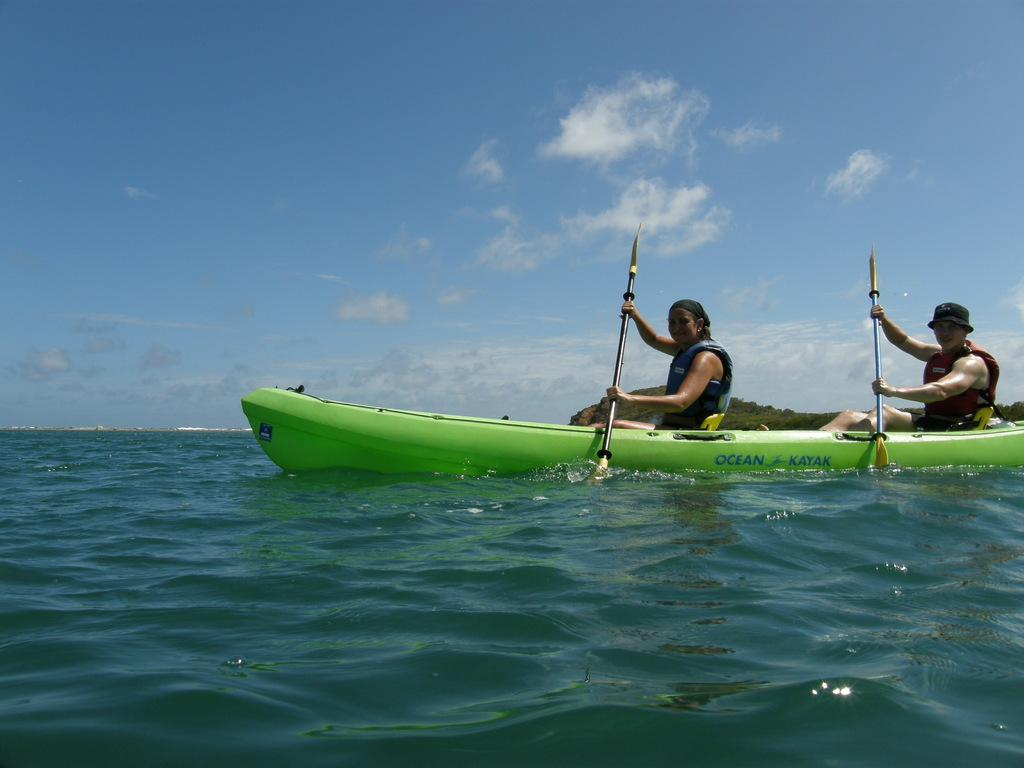How many people are in the image? There is a man and a woman in the image. What are they doing in the image? They are sailing a boat. How is the boat being powered? The boat is being rowed. What can be seen in the background of the image? There is a hill and the sky visible in the background. What is the condition of the sky in the image? The sky appears to be cloudy. What type of parcel is being exchanged between the man and the woman in the image? There is no parcel being exchanged between the man and the woman in the image; they are sailing a boat. What color is the light emitted by the boat in the image? There is no light emitted by the boat in the image; it is being rowed. 